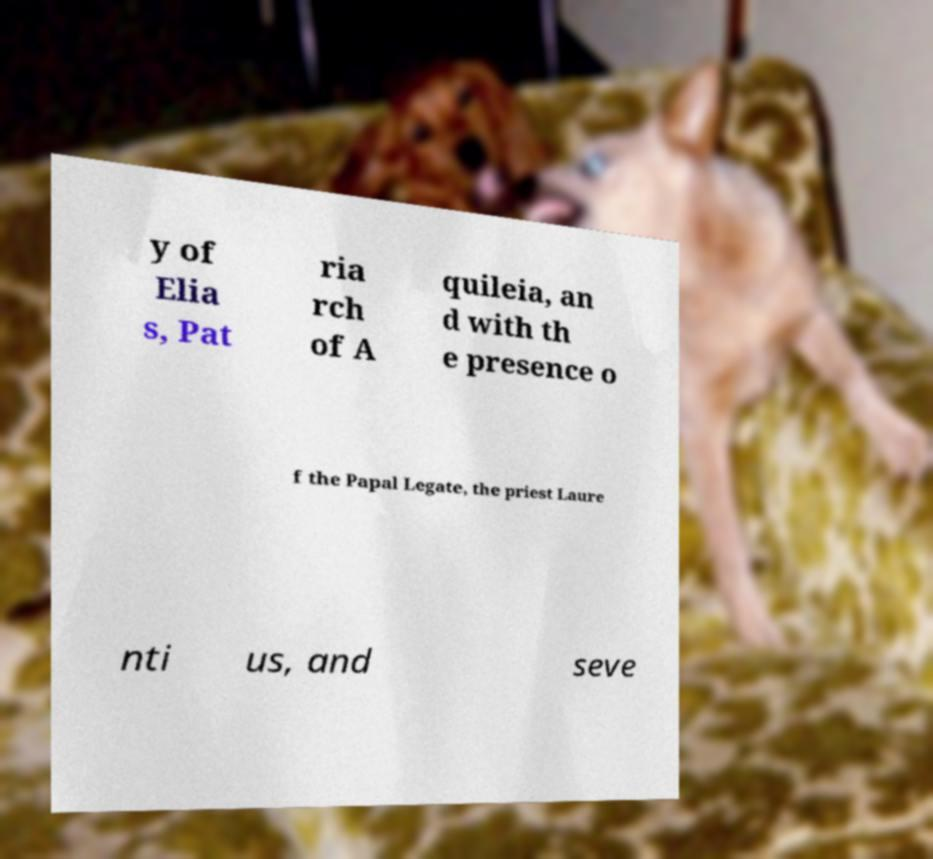Can you read and provide the text displayed in the image?This photo seems to have some interesting text. Can you extract and type it out for me? y of Elia s, Pat ria rch of A quileia, an d with th e presence o f the Papal Legate, the priest Laure nti us, and seve 